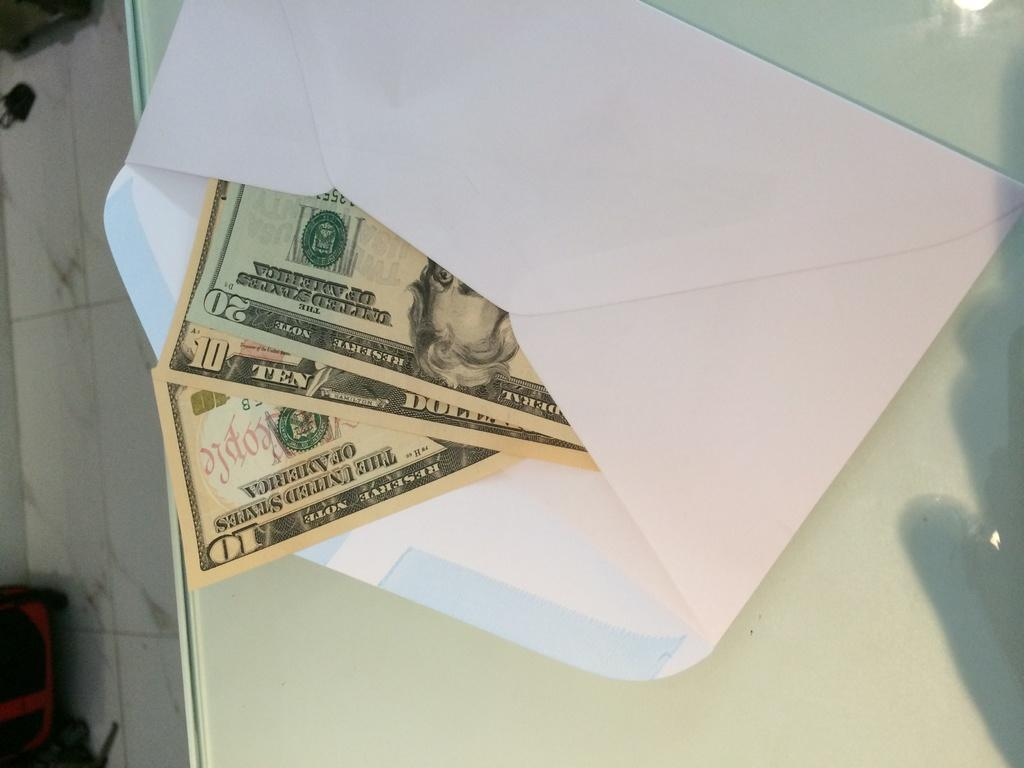Provide a one-sentence caption for the provided image. A 10 and 20 dollar note in an envelope. 